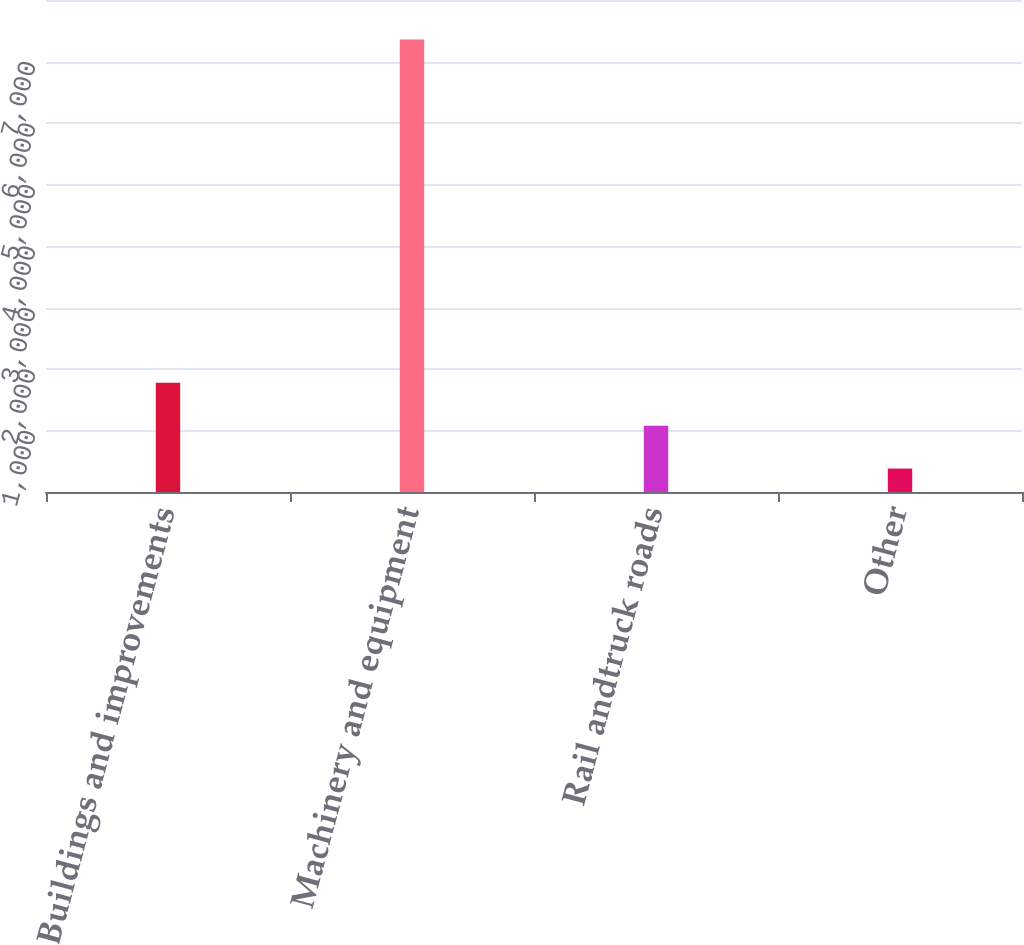<chart> <loc_0><loc_0><loc_500><loc_500><bar_chart><fcel>Buildings and improvements<fcel>Machinery and equipment<fcel>Rail andtruck roads<fcel>Other<nl><fcel>1776.4<fcel>7358<fcel>1078.7<fcel>381<nl></chart> 